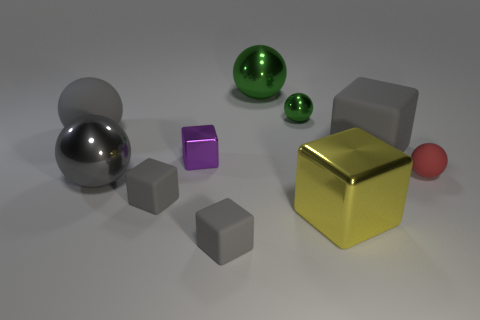Is the block right of the yellow metallic object made of the same material as the gray sphere in front of the tiny red rubber object?
Offer a very short reply. No. Are there the same number of purple cubes in front of the yellow metal block and gray rubber balls right of the red matte thing?
Keep it short and to the point. Yes. What material is the large sphere in front of the purple metallic thing?
Give a very brief answer. Metal. Is there anything else that has the same size as the yellow thing?
Give a very brief answer. Yes. Are there fewer small matte cubes than small purple cubes?
Keep it short and to the point. No. The metallic object that is to the left of the big green shiny object and in front of the tiny shiny cube has what shape?
Offer a very short reply. Sphere. What number of metal cubes are there?
Keep it short and to the point. 2. There is a big gray object left of the big gray thing that is in front of the small ball in front of the purple object; what is its material?
Ensure brevity in your answer.  Rubber. There is a large gray ball in front of the large matte cube; what number of small objects are in front of it?
Ensure brevity in your answer.  2. There is another small thing that is the same shape as the tiny red rubber thing; what is its color?
Your answer should be compact. Green. 